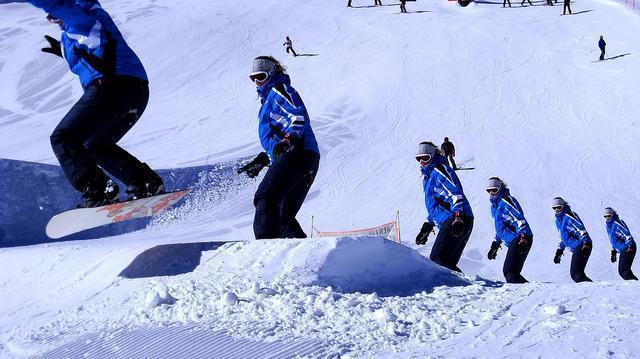What technique was used to manipulate this photo?
Select the accurate answer and provide justification: `Answer: choice
Rationale: srationale.`
Options: Blending, cloning, time lapse, superimposition. Answer: time lapse.
Rationale: The technique is time lapse. 